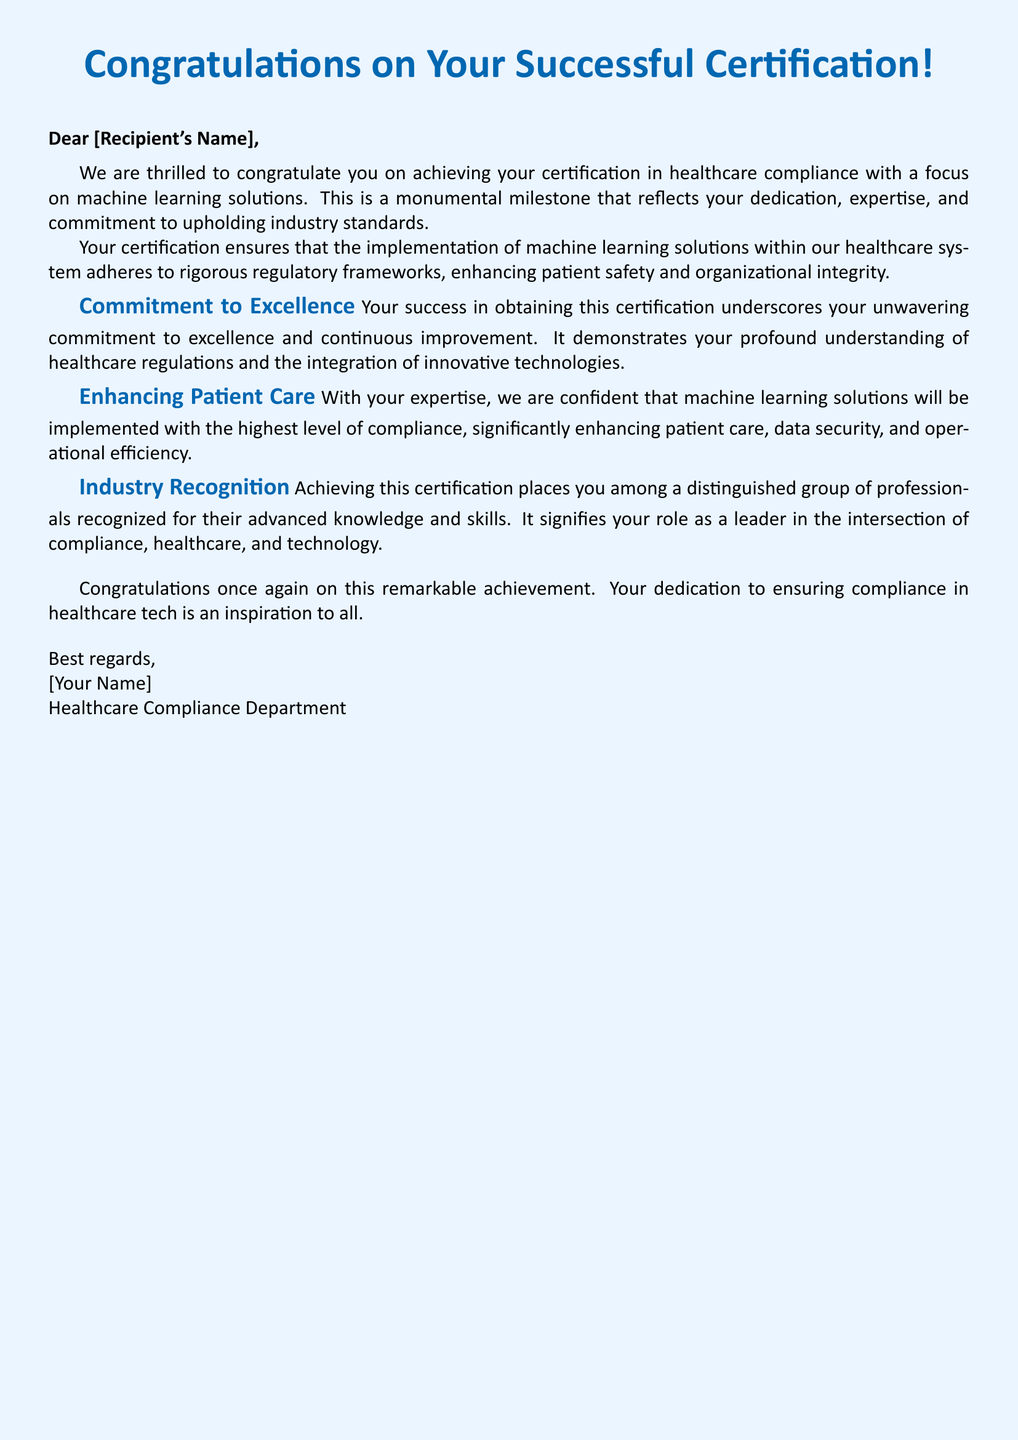What is the title of the document? The title is prominently displayed at the top of the document, highlighting the purpose of the greeting card.
Answer: Congratulations on Your Successful Certification! What is the main color used in the document? The document predominantly uses a specific color for its title and headings, contributing to its visual theme.
Answer: healthblue Who is the greeting card addressed to? The greeting card includes a placeholder for the recipient's name, indicating personalization.
Answer: [Recipient's Name] Which department is sending the congratulations? The signature at the end of the document identifies the sender's affiliation, indicating the source of the congratulatory message.
Answer: Healthcare Compliance Department What does the certification focus on? The document mentions a specific area related to compliance and technology, indicating the scope of the recipient's achievement.
Answer: machine learning solutions Why is the certification considered a monumental milestone? The document elaborates on the significance of the certification in terms of dedication and compliance.
Answer: dedication, expertise, and commitment What does the certification enhance in patient care? The document states the impact of the recipient's certification on healthcare and technology, specifically mentioning a critical aspect.
Answer: patient safety How is the recipient recognized in the field? The document highlights the recipient's status among peers in their professional field, emphasizing their advanced qualifications.
Answer: distinguished group of professionals What is the closing remark of the document? The document concludes with a message reiterating the importance of the recipient's achievement.
Answer: Congratulations once again on this remarkable achievement 